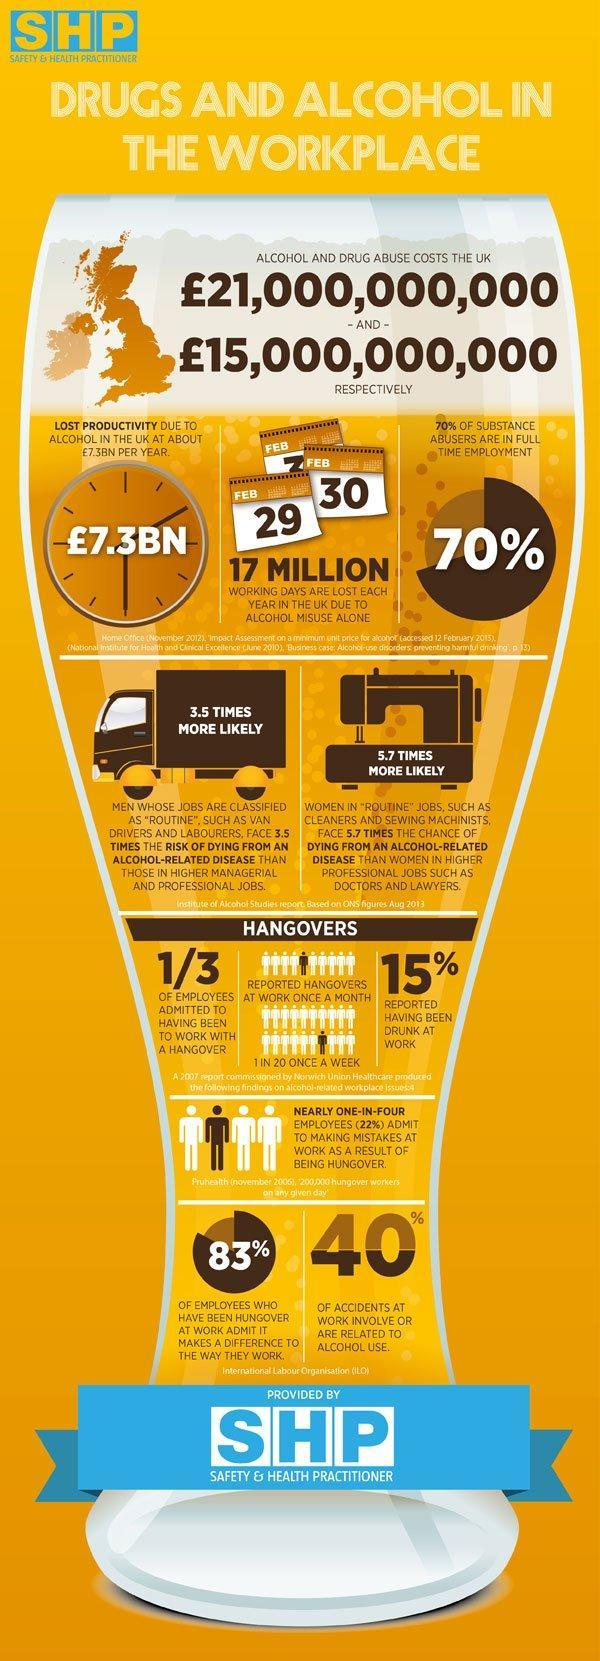How many clocks are in this infographic?
Answer the question with a short phrase. 1 What percentage of substance abusers are not in full-time employment? 30% How many calendars are in this infographic? 3 What is the percentage of accidents not related to alcohol use? 60% 